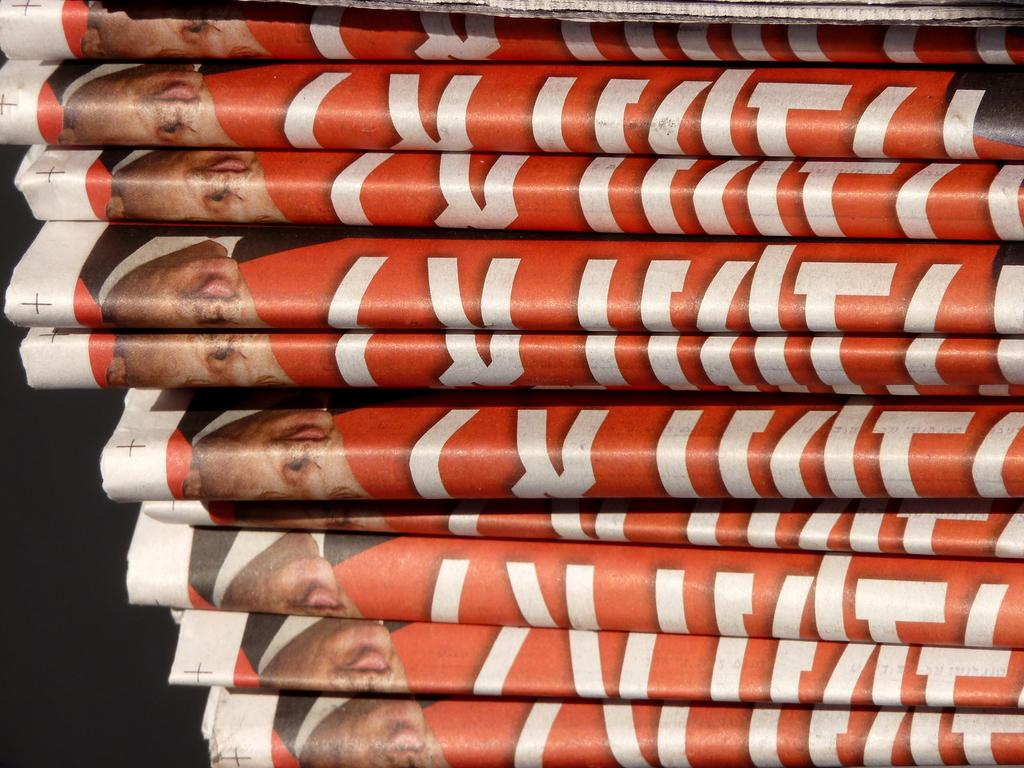What is present on the papers in the image? The papers have letters and faces of people on them. Can you describe the content of the letters on the papers? Unfortunately, the specific content of the letters cannot be determined from the image. What is visible on the left side bottom of the image? There is a dark view on the left side bottom of the image. What type of lipstick is the police officer wearing in the image? There is no police officer or lipstick present in the image. What type of food is being served in the lunchroom in the image? There is no lunchroom present in the image. 